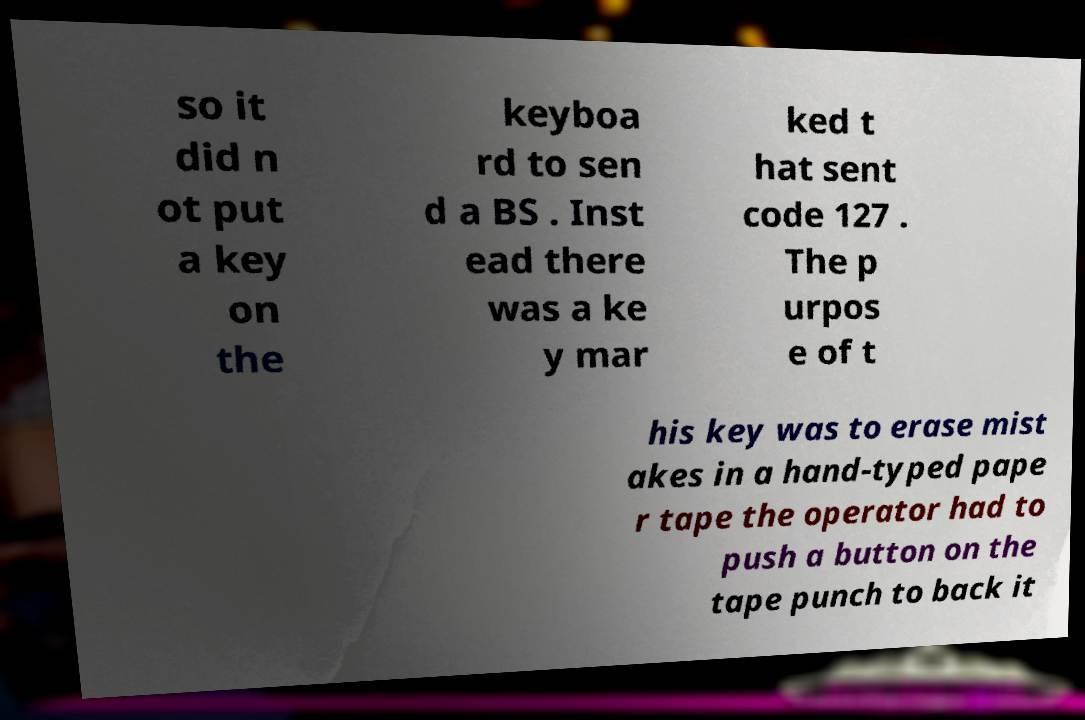Could you extract and type out the text from this image? so it did n ot put a key on the keyboa rd to sen d a BS . Inst ead there was a ke y mar ked t hat sent code 127 . The p urpos e of t his key was to erase mist akes in a hand-typed pape r tape the operator had to push a button on the tape punch to back it 